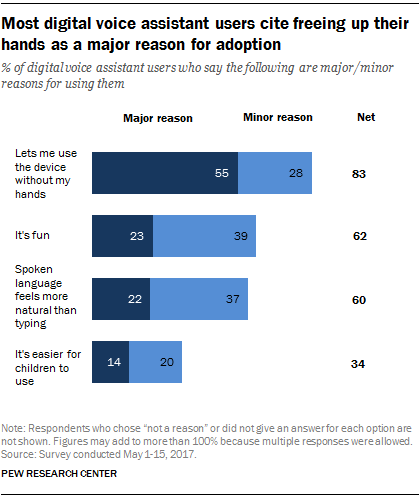Draw attention to some important aspects in this diagram. The value of the longest blue bar is 0.55. The difference between major reasons and minor reasons seen as fun is 0.16. 